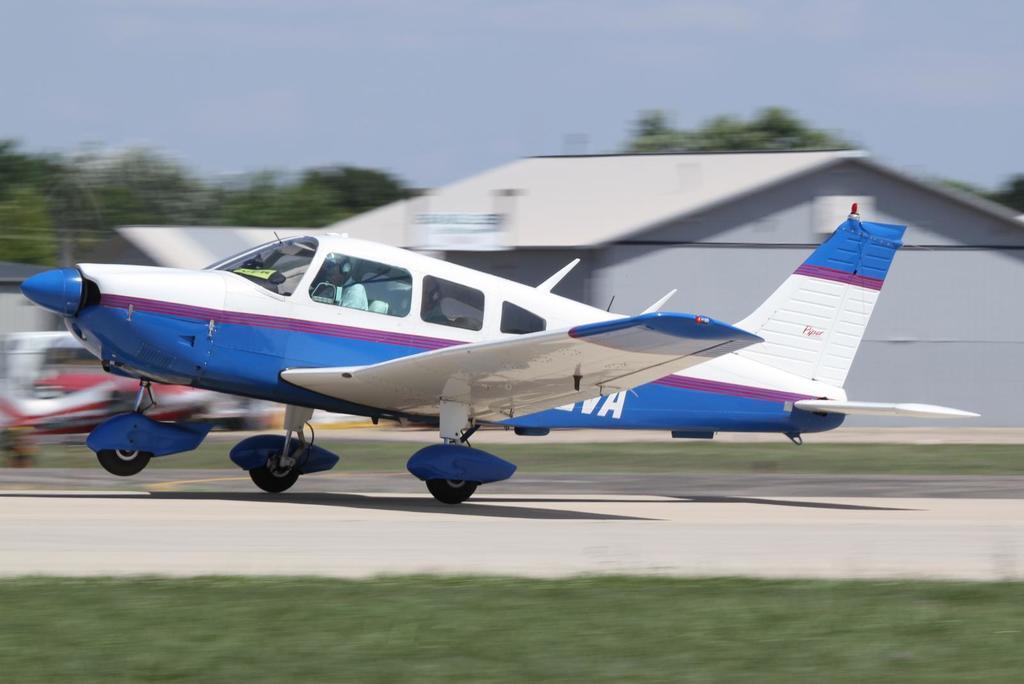In one or two sentences, can you explain what this image depicts? In this image there is an airplane on a runway, in the background there is a shed, trees and the sky and it is blurred, in the foreground there is grass. 